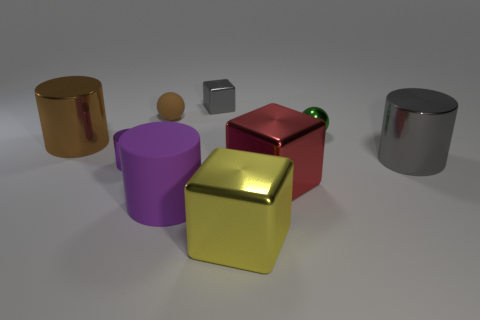Assuming the larger objects weigh more, which of these objects do you think could be lifted by an average adult? An average adult could likely lift the smaller objects with ease—the purple cylinder, tiny metallic cube, and the small wooden sphere, given their size implies lighter weight. The larger objects, such as the golden cylinder, red cube, and silver cylinder might require more effort but seem manageable. The green sphere atop the red cube might be the lightest of all, based on its diminutive size and position. 